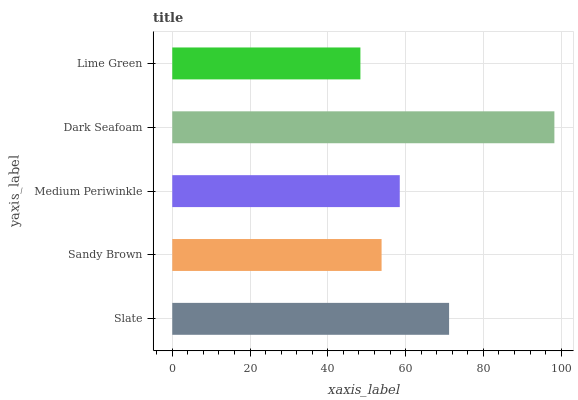Is Lime Green the minimum?
Answer yes or no. Yes. Is Dark Seafoam the maximum?
Answer yes or no. Yes. Is Sandy Brown the minimum?
Answer yes or no. No. Is Sandy Brown the maximum?
Answer yes or no. No. Is Slate greater than Sandy Brown?
Answer yes or no. Yes. Is Sandy Brown less than Slate?
Answer yes or no. Yes. Is Sandy Brown greater than Slate?
Answer yes or no. No. Is Slate less than Sandy Brown?
Answer yes or no. No. Is Medium Periwinkle the high median?
Answer yes or no. Yes. Is Medium Periwinkle the low median?
Answer yes or no. Yes. Is Lime Green the high median?
Answer yes or no. No. Is Dark Seafoam the low median?
Answer yes or no. No. 